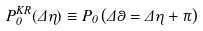<formula> <loc_0><loc_0><loc_500><loc_500>P _ { 0 } ^ { K R } ( \Delta \eta ) \equiv P _ { 0 } \left ( \Delta \theta = \Delta \eta + \pi \right )</formula> 